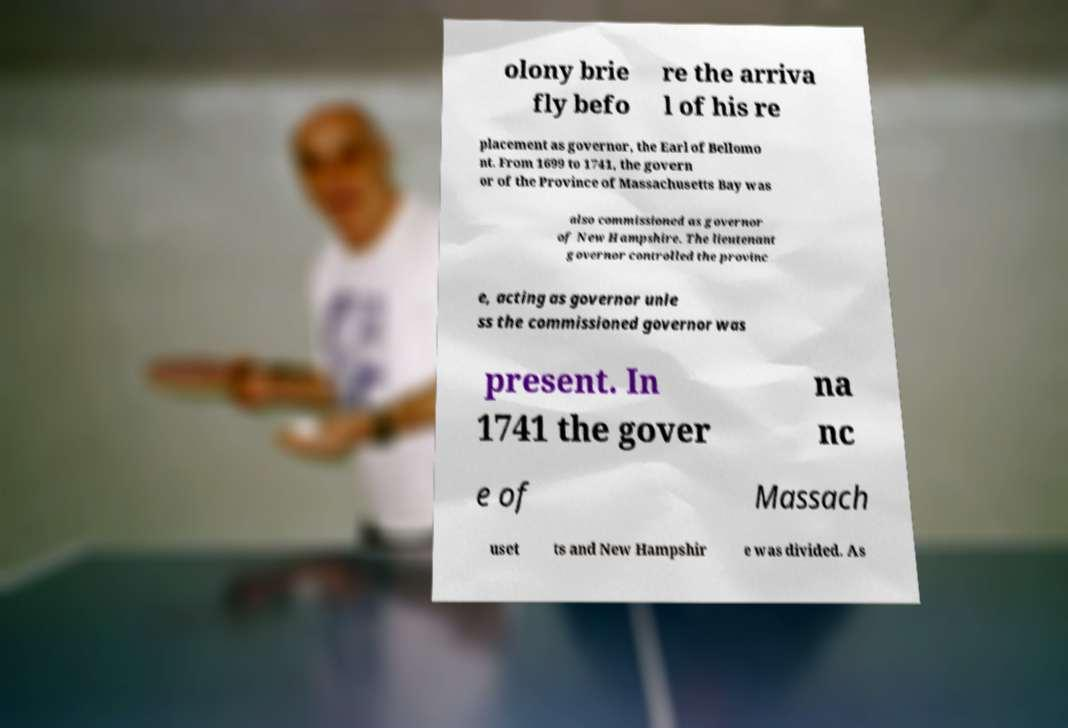Could you assist in decoding the text presented in this image and type it out clearly? olony brie fly befo re the arriva l of his re placement as governor, the Earl of Bellomo nt. From 1699 to 1741, the govern or of the Province of Massachusetts Bay was also commissioned as governor of New Hampshire. The lieutenant governor controlled the provinc e, acting as governor unle ss the commissioned governor was present. In 1741 the gover na nc e of Massach uset ts and New Hampshir e was divided. As 